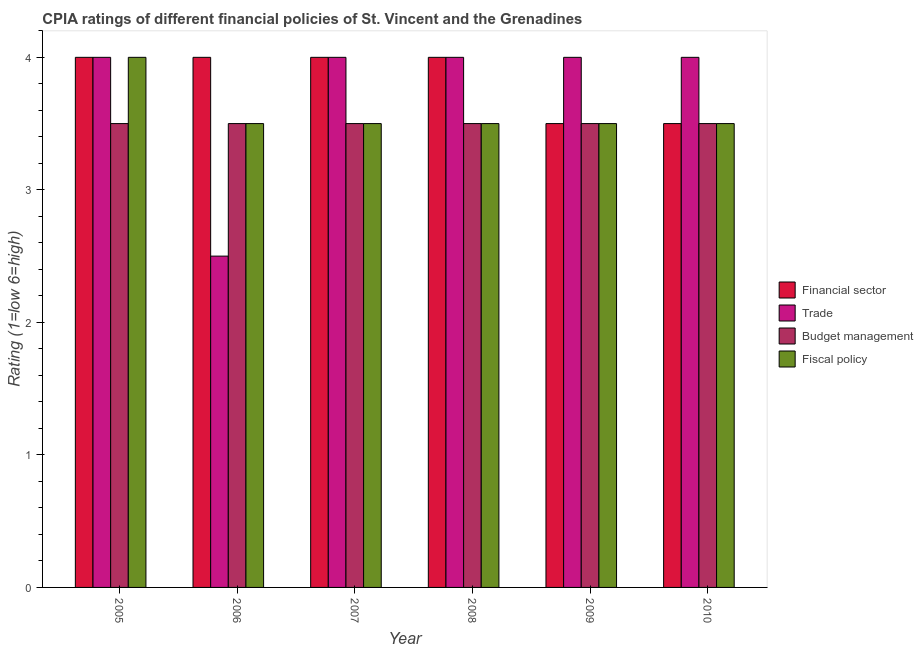How many bars are there on the 3rd tick from the right?
Provide a short and direct response. 4. What is the label of the 3rd group of bars from the left?
Provide a short and direct response. 2007. In how many cases, is the number of bars for a given year not equal to the number of legend labels?
Make the answer very short. 0. What is the cpia rating of trade in 2007?
Provide a succinct answer. 4. Across all years, what is the maximum cpia rating of financial sector?
Offer a very short reply. 4. Across all years, what is the minimum cpia rating of budget management?
Provide a short and direct response. 3.5. In which year was the cpia rating of budget management maximum?
Provide a succinct answer. 2005. What is the total cpia rating of financial sector in the graph?
Provide a short and direct response. 23. What is the difference between the cpia rating of financial sector in 2009 and the cpia rating of budget management in 2006?
Keep it short and to the point. -0.5. What is the average cpia rating of fiscal policy per year?
Provide a succinct answer. 3.58. In the year 2005, what is the difference between the cpia rating of budget management and cpia rating of trade?
Provide a short and direct response. 0. What is the ratio of the cpia rating of fiscal policy in 2009 to that in 2010?
Keep it short and to the point. 1. Is the cpia rating of fiscal policy in 2006 less than that in 2009?
Offer a very short reply. No. Is the difference between the cpia rating of budget management in 2005 and 2007 greater than the difference between the cpia rating of trade in 2005 and 2007?
Your answer should be compact. No. What is the difference between the highest and the second highest cpia rating of financial sector?
Provide a short and direct response. 0. What is the difference between the highest and the lowest cpia rating of fiscal policy?
Make the answer very short. 0.5. In how many years, is the cpia rating of budget management greater than the average cpia rating of budget management taken over all years?
Provide a short and direct response. 0. What does the 1st bar from the left in 2009 represents?
Your answer should be compact. Financial sector. What does the 1st bar from the right in 2007 represents?
Your response must be concise. Fiscal policy. Is it the case that in every year, the sum of the cpia rating of financial sector and cpia rating of trade is greater than the cpia rating of budget management?
Give a very brief answer. Yes. How many legend labels are there?
Offer a very short reply. 4. What is the title of the graph?
Keep it short and to the point. CPIA ratings of different financial policies of St. Vincent and the Grenadines. Does "Secondary general" appear as one of the legend labels in the graph?
Offer a terse response. No. What is the label or title of the X-axis?
Provide a short and direct response. Year. What is the label or title of the Y-axis?
Provide a succinct answer. Rating (1=low 6=high). What is the Rating (1=low 6=high) in Financial sector in 2005?
Offer a very short reply. 4. What is the Rating (1=low 6=high) in Fiscal policy in 2005?
Your response must be concise. 4. What is the Rating (1=low 6=high) in Financial sector in 2006?
Make the answer very short. 4. What is the Rating (1=low 6=high) in Trade in 2006?
Your answer should be very brief. 2.5. What is the Rating (1=low 6=high) of Fiscal policy in 2006?
Keep it short and to the point. 3.5. What is the Rating (1=low 6=high) of Budget management in 2007?
Your answer should be very brief. 3.5. What is the Rating (1=low 6=high) in Trade in 2008?
Make the answer very short. 4. What is the Rating (1=low 6=high) in Budget management in 2008?
Offer a very short reply. 3.5. What is the Rating (1=low 6=high) in Financial sector in 2009?
Give a very brief answer. 3.5. What is the Rating (1=low 6=high) of Trade in 2010?
Ensure brevity in your answer.  4. What is the Rating (1=low 6=high) of Budget management in 2010?
Provide a succinct answer. 3.5. What is the Rating (1=low 6=high) in Fiscal policy in 2010?
Your answer should be very brief. 3.5. Across all years, what is the maximum Rating (1=low 6=high) of Financial sector?
Offer a terse response. 4. Across all years, what is the minimum Rating (1=low 6=high) in Financial sector?
Make the answer very short. 3.5. What is the total Rating (1=low 6=high) of Financial sector in the graph?
Provide a succinct answer. 23. What is the total Rating (1=low 6=high) in Budget management in the graph?
Your answer should be compact. 21. What is the difference between the Rating (1=low 6=high) of Financial sector in 2005 and that in 2006?
Ensure brevity in your answer.  0. What is the difference between the Rating (1=low 6=high) of Budget management in 2005 and that in 2007?
Provide a succinct answer. 0. What is the difference between the Rating (1=low 6=high) of Budget management in 2005 and that in 2008?
Your response must be concise. 0. What is the difference between the Rating (1=low 6=high) in Fiscal policy in 2005 and that in 2008?
Your response must be concise. 0.5. What is the difference between the Rating (1=low 6=high) of Trade in 2005 and that in 2009?
Your answer should be compact. 0. What is the difference between the Rating (1=low 6=high) in Fiscal policy in 2005 and that in 2009?
Provide a succinct answer. 0.5. What is the difference between the Rating (1=low 6=high) of Financial sector in 2005 and that in 2010?
Offer a terse response. 0.5. What is the difference between the Rating (1=low 6=high) of Budget management in 2005 and that in 2010?
Ensure brevity in your answer.  0. What is the difference between the Rating (1=low 6=high) in Trade in 2006 and that in 2007?
Give a very brief answer. -1.5. What is the difference between the Rating (1=low 6=high) in Fiscal policy in 2006 and that in 2007?
Ensure brevity in your answer.  0. What is the difference between the Rating (1=low 6=high) of Fiscal policy in 2006 and that in 2008?
Make the answer very short. 0. What is the difference between the Rating (1=low 6=high) of Fiscal policy in 2006 and that in 2009?
Ensure brevity in your answer.  0. What is the difference between the Rating (1=low 6=high) of Financial sector in 2006 and that in 2010?
Your answer should be compact. 0.5. What is the difference between the Rating (1=low 6=high) of Trade in 2007 and that in 2008?
Make the answer very short. 0. What is the difference between the Rating (1=low 6=high) of Trade in 2007 and that in 2009?
Make the answer very short. 0. What is the difference between the Rating (1=low 6=high) of Budget management in 2007 and that in 2009?
Keep it short and to the point. 0. What is the difference between the Rating (1=low 6=high) of Fiscal policy in 2007 and that in 2009?
Provide a short and direct response. 0. What is the difference between the Rating (1=low 6=high) of Financial sector in 2007 and that in 2010?
Provide a succinct answer. 0.5. What is the difference between the Rating (1=low 6=high) of Fiscal policy in 2008 and that in 2009?
Your response must be concise. 0. What is the difference between the Rating (1=low 6=high) in Trade in 2008 and that in 2010?
Give a very brief answer. 0. What is the difference between the Rating (1=low 6=high) of Trade in 2009 and that in 2010?
Your answer should be very brief. 0. What is the difference between the Rating (1=low 6=high) of Fiscal policy in 2009 and that in 2010?
Ensure brevity in your answer.  0. What is the difference between the Rating (1=low 6=high) of Financial sector in 2005 and the Rating (1=low 6=high) of Trade in 2006?
Keep it short and to the point. 1.5. What is the difference between the Rating (1=low 6=high) in Financial sector in 2005 and the Rating (1=low 6=high) in Budget management in 2006?
Provide a short and direct response. 0.5. What is the difference between the Rating (1=low 6=high) in Financial sector in 2005 and the Rating (1=low 6=high) in Fiscal policy in 2006?
Offer a terse response. 0.5. What is the difference between the Rating (1=low 6=high) of Trade in 2005 and the Rating (1=low 6=high) of Budget management in 2006?
Ensure brevity in your answer.  0.5. What is the difference between the Rating (1=low 6=high) of Trade in 2005 and the Rating (1=low 6=high) of Fiscal policy in 2006?
Provide a short and direct response. 0.5. What is the difference between the Rating (1=low 6=high) of Financial sector in 2005 and the Rating (1=low 6=high) of Trade in 2007?
Provide a succinct answer. 0. What is the difference between the Rating (1=low 6=high) of Financial sector in 2005 and the Rating (1=low 6=high) of Fiscal policy in 2007?
Ensure brevity in your answer.  0.5. What is the difference between the Rating (1=low 6=high) of Trade in 2005 and the Rating (1=low 6=high) of Fiscal policy in 2007?
Provide a short and direct response. 0.5. What is the difference between the Rating (1=low 6=high) in Budget management in 2005 and the Rating (1=low 6=high) in Fiscal policy in 2007?
Ensure brevity in your answer.  0. What is the difference between the Rating (1=low 6=high) of Financial sector in 2005 and the Rating (1=low 6=high) of Budget management in 2008?
Your response must be concise. 0.5. What is the difference between the Rating (1=low 6=high) of Trade in 2005 and the Rating (1=low 6=high) of Budget management in 2008?
Offer a terse response. 0.5. What is the difference between the Rating (1=low 6=high) of Trade in 2005 and the Rating (1=low 6=high) of Fiscal policy in 2008?
Offer a terse response. 0.5. What is the difference between the Rating (1=low 6=high) in Budget management in 2005 and the Rating (1=low 6=high) in Fiscal policy in 2008?
Your response must be concise. 0. What is the difference between the Rating (1=low 6=high) of Financial sector in 2005 and the Rating (1=low 6=high) of Trade in 2009?
Give a very brief answer. 0. What is the difference between the Rating (1=low 6=high) of Financial sector in 2005 and the Rating (1=low 6=high) of Budget management in 2009?
Offer a very short reply. 0.5. What is the difference between the Rating (1=low 6=high) in Trade in 2005 and the Rating (1=low 6=high) in Budget management in 2009?
Your answer should be very brief. 0.5. What is the difference between the Rating (1=low 6=high) in Trade in 2005 and the Rating (1=low 6=high) in Budget management in 2010?
Your answer should be compact. 0.5. What is the difference between the Rating (1=low 6=high) of Trade in 2005 and the Rating (1=low 6=high) of Fiscal policy in 2010?
Your response must be concise. 0.5. What is the difference between the Rating (1=low 6=high) in Financial sector in 2006 and the Rating (1=low 6=high) in Fiscal policy in 2007?
Keep it short and to the point. 0.5. What is the difference between the Rating (1=low 6=high) of Financial sector in 2006 and the Rating (1=low 6=high) of Fiscal policy in 2008?
Provide a succinct answer. 0.5. What is the difference between the Rating (1=low 6=high) of Trade in 2006 and the Rating (1=low 6=high) of Budget management in 2008?
Your answer should be compact. -1. What is the difference between the Rating (1=low 6=high) of Trade in 2006 and the Rating (1=low 6=high) of Fiscal policy in 2008?
Offer a terse response. -1. What is the difference between the Rating (1=low 6=high) in Budget management in 2006 and the Rating (1=low 6=high) in Fiscal policy in 2008?
Make the answer very short. 0. What is the difference between the Rating (1=low 6=high) in Financial sector in 2006 and the Rating (1=low 6=high) in Budget management in 2009?
Ensure brevity in your answer.  0.5. What is the difference between the Rating (1=low 6=high) of Financial sector in 2006 and the Rating (1=low 6=high) of Fiscal policy in 2009?
Your answer should be compact. 0.5. What is the difference between the Rating (1=low 6=high) of Trade in 2006 and the Rating (1=low 6=high) of Fiscal policy in 2009?
Keep it short and to the point. -1. What is the difference between the Rating (1=low 6=high) in Budget management in 2006 and the Rating (1=low 6=high) in Fiscal policy in 2009?
Provide a succinct answer. 0. What is the difference between the Rating (1=low 6=high) of Financial sector in 2006 and the Rating (1=low 6=high) of Trade in 2010?
Give a very brief answer. 0. What is the difference between the Rating (1=low 6=high) in Financial sector in 2006 and the Rating (1=low 6=high) in Fiscal policy in 2010?
Offer a terse response. 0.5. What is the difference between the Rating (1=low 6=high) in Budget management in 2006 and the Rating (1=low 6=high) in Fiscal policy in 2010?
Your response must be concise. 0. What is the difference between the Rating (1=low 6=high) of Financial sector in 2007 and the Rating (1=low 6=high) of Budget management in 2008?
Your answer should be compact. 0.5. What is the difference between the Rating (1=low 6=high) of Trade in 2007 and the Rating (1=low 6=high) of Budget management in 2008?
Offer a terse response. 0.5. What is the difference between the Rating (1=low 6=high) of Financial sector in 2007 and the Rating (1=low 6=high) of Fiscal policy in 2009?
Make the answer very short. 0.5. What is the difference between the Rating (1=low 6=high) of Trade in 2007 and the Rating (1=low 6=high) of Budget management in 2009?
Offer a terse response. 0.5. What is the difference between the Rating (1=low 6=high) in Trade in 2007 and the Rating (1=low 6=high) in Fiscal policy in 2009?
Make the answer very short. 0.5. What is the difference between the Rating (1=low 6=high) of Budget management in 2007 and the Rating (1=low 6=high) of Fiscal policy in 2009?
Your answer should be very brief. 0. What is the difference between the Rating (1=low 6=high) of Financial sector in 2007 and the Rating (1=low 6=high) of Budget management in 2010?
Provide a short and direct response. 0.5. What is the difference between the Rating (1=low 6=high) in Financial sector in 2007 and the Rating (1=low 6=high) in Fiscal policy in 2010?
Your response must be concise. 0.5. What is the difference between the Rating (1=low 6=high) in Trade in 2007 and the Rating (1=low 6=high) in Budget management in 2010?
Offer a very short reply. 0.5. What is the difference between the Rating (1=low 6=high) in Budget management in 2007 and the Rating (1=low 6=high) in Fiscal policy in 2010?
Ensure brevity in your answer.  0. What is the difference between the Rating (1=low 6=high) of Financial sector in 2008 and the Rating (1=low 6=high) of Budget management in 2009?
Provide a succinct answer. 0.5. What is the difference between the Rating (1=low 6=high) in Trade in 2008 and the Rating (1=low 6=high) in Budget management in 2009?
Ensure brevity in your answer.  0.5. What is the difference between the Rating (1=low 6=high) in Trade in 2008 and the Rating (1=low 6=high) in Fiscal policy in 2009?
Offer a terse response. 0.5. What is the difference between the Rating (1=low 6=high) of Budget management in 2008 and the Rating (1=low 6=high) of Fiscal policy in 2009?
Offer a terse response. 0. What is the difference between the Rating (1=low 6=high) in Financial sector in 2008 and the Rating (1=low 6=high) in Trade in 2010?
Give a very brief answer. 0. What is the difference between the Rating (1=low 6=high) of Financial sector in 2008 and the Rating (1=low 6=high) of Budget management in 2010?
Provide a short and direct response. 0.5. What is the difference between the Rating (1=low 6=high) of Financial sector in 2008 and the Rating (1=low 6=high) of Fiscal policy in 2010?
Offer a terse response. 0.5. What is the difference between the Rating (1=low 6=high) of Financial sector in 2009 and the Rating (1=low 6=high) of Budget management in 2010?
Your answer should be compact. 0. What is the difference between the Rating (1=low 6=high) in Trade in 2009 and the Rating (1=low 6=high) in Budget management in 2010?
Provide a short and direct response. 0.5. What is the difference between the Rating (1=low 6=high) in Trade in 2009 and the Rating (1=low 6=high) in Fiscal policy in 2010?
Give a very brief answer. 0.5. What is the average Rating (1=low 6=high) of Financial sector per year?
Your answer should be very brief. 3.83. What is the average Rating (1=low 6=high) of Trade per year?
Provide a short and direct response. 3.75. What is the average Rating (1=low 6=high) in Budget management per year?
Make the answer very short. 3.5. What is the average Rating (1=low 6=high) in Fiscal policy per year?
Your answer should be compact. 3.58. In the year 2005, what is the difference between the Rating (1=low 6=high) of Financial sector and Rating (1=low 6=high) of Trade?
Your answer should be very brief. 0. In the year 2005, what is the difference between the Rating (1=low 6=high) of Financial sector and Rating (1=low 6=high) of Budget management?
Keep it short and to the point. 0.5. In the year 2005, what is the difference between the Rating (1=low 6=high) in Trade and Rating (1=low 6=high) in Fiscal policy?
Offer a terse response. 0. In the year 2006, what is the difference between the Rating (1=low 6=high) of Financial sector and Rating (1=low 6=high) of Trade?
Your response must be concise. 1.5. In the year 2006, what is the difference between the Rating (1=low 6=high) in Financial sector and Rating (1=low 6=high) in Budget management?
Provide a short and direct response. 0.5. In the year 2006, what is the difference between the Rating (1=low 6=high) of Financial sector and Rating (1=low 6=high) of Fiscal policy?
Make the answer very short. 0.5. In the year 2006, what is the difference between the Rating (1=low 6=high) of Trade and Rating (1=low 6=high) of Fiscal policy?
Ensure brevity in your answer.  -1. In the year 2006, what is the difference between the Rating (1=low 6=high) in Budget management and Rating (1=low 6=high) in Fiscal policy?
Offer a very short reply. 0. In the year 2007, what is the difference between the Rating (1=low 6=high) in Financial sector and Rating (1=low 6=high) in Budget management?
Provide a short and direct response. 0.5. In the year 2007, what is the difference between the Rating (1=low 6=high) of Financial sector and Rating (1=low 6=high) of Fiscal policy?
Give a very brief answer. 0.5. In the year 2007, what is the difference between the Rating (1=low 6=high) of Trade and Rating (1=low 6=high) of Fiscal policy?
Offer a terse response. 0.5. In the year 2007, what is the difference between the Rating (1=low 6=high) in Budget management and Rating (1=low 6=high) in Fiscal policy?
Keep it short and to the point. 0. In the year 2008, what is the difference between the Rating (1=low 6=high) in Financial sector and Rating (1=low 6=high) in Trade?
Give a very brief answer. 0. In the year 2008, what is the difference between the Rating (1=low 6=high) of Financial sector and Rating (1=low 6=high) of Budget management?
Offer a terse response. 0.5. In the year 2008, what is the difference between the Rating (1=low 6=high) in Trade and Rating (1=low 6=high) in Fiscal policy?
Provide a short and direct response. 0.5. In the year 2009, what is the difference between the Rating (1=low 6=high) of Financial sector and Rating (1=low 6=high) of Budget management?
Ensure brevity in your answer.  0. In the year 2009, what is the difference between the Rating (1=low 6=high) of Financial sector and Rating (1=low 6=high) of Fiscal policy?
Your response must be concise. 0. In the year 2009, what is the difference between the Rating (1=low 6=high) of Trade and Rating (1=low 6=high) of Fiscal policy?
Ensure brevity in your answer.  0.5. In the year 2010, what is the difference between the Rating (1=low 6=high) in Financial sector and Rating (1=low 6=high) in Budget management?
Your answer should be very brief. 0. In the year 2010, what is the difference between the Rating (1=low 6=high) of Trade and Rating (1=low 6=high) of Fiscal policy?
Your answer should be compact. 0.5. What is the ratio of the Rating (1=low 6=high) in Financial sector in 2005 to that in 2006?
Make the answer very short. 1. What is the ratio of the Rating (1=low 6=high) in Budget management in 2005 to that in 2006?
Make the answer very short. 1. What is the ratio of the Rating (1=low 6=high) in Fiscal policy in 2005 to that in 2006?
Give a very brief answer. 1.14. What is the ratio of the Rating (1=low 6=high) in Fiscal policy in 2005 to that in 2007?
Your answer should be very brief. 1.14. What is the ratio of the Rating (1=low 6=high) in Financial sector in 2005 to that in 2008?
Ensure brevity in your answer.  1. What is the ratio of the Rating (1=low 6=high) of Financial sector in 2005 to that in 2009?
Make the answer very short. 1.14. What is the ratio of the Rating (1=low 6=high) in Trade in 2005 to that in 2009?
Offer a very short reply. 1. What is the ratio of the Rating (1=low 6=high) in Budget management in 2005 to that in 2009?
Give a very brief answer. 1. What is the ratio of the Rating (1=low 6=high) in Budget management in 2005 to that in 2010?
Your answer should be very brief. 1. What is the ratio of the Rating (1=low 6=high) of Financial sector in 2006 to that in 2007?
Your answer should be very brief. 1. What is the ratio of the Rating (1=low 6=high) of Budget management in 2006 to that in 2007?
Your response must be concise. 1. What is the ratio of the Rating (1=low 6=high) in Trade in 2006 to that in 2008?
Make the answer very short. 0.62. What is the ratio of the Rating (1=low 6=high) in Financial sector in 2006 to that in 2009?
Offer a terse response. 1.14. What is the ratio of the Rating (1=low 6=high) of Fiscal policy in 2006 to that in 2009?
Offer a terse response. 1. What is the ratio of the Rating (1=low 6=high) in Financial sector in 2006 to that in 2010?
Offer a very short reply. 1.14. What is the ratio of the Rating (1=low 6=high) in Budget management in 2006 to that in 2010?
Offer a terse response. 1. What is the ratio of the Rating (1=low 6=high) in Fiscal policy in 2006 to that in 2010?
Ensure brevity in your answer.  1. What is the ratio of the Rating (1=low 6=high) in Trade in 2007 to that in 2008?
Ensure brevity in your answer.  1. What is the ratio of the Rating (1=low 6=high) of Budget management in 2007 to that in 2008?
Your answer should be compact. 1. What is the ratio of the Rating (1=low 6=high) of Fiscal policy in 2007 to that in 2008?
Your response must be concise. 1. What is the ratio of the Rating (1=low 6=high) in Financial sector in 2007 to that in 2009?
Give a very brief answer. 1.14. What is the ratio of the Rating (1=low 6=high) in Trade in 2007 to that in 2009?
Keep it short and to the point. 1. What is the ratio of the Rating (1=low 6=high) of Budget management in 2007 to that in 2009?
Your answer should be compact. 1. What is the ratio of the Rating (1=low 6=high) in Financial sector in 2007 to that in 2010?
Make the answer very short. 1.14. What is the ratio of the Rating (1=low 6=high) of Trade in 2007 to that in 2010?
Make the answer very short. 1. What is the ratio of the Rating (1=low 6=high) of Financial sector in 2008 to that in 2009?
Keep it short and to the point. 1.14. What is the ratio of the Rating (1=low 6=high) in Trade in 2008 to that in 2009?
Offer a terse response. 1. What is the ratio of the Rating (1=low 6=high) in Budget management in 2008 to that in 2009?
Ensure brevity in your answer.  1. What is the ratio of the Rating (1=low 6=high) of Fiscal policy in 2008 to that in 2009?
Your answer should be very brief. 1. What is the ratio of the Rating (1=low 6=high) in Budget management in 2008 to that in 2010?
Offer a terse response. 1. What is the ratio of the Rating (1=low 6=high) of Fiscal policy in 2008 to that in 2010?
Your answer should be compact. 1. What is the difference between the highest and the second highest Rating (1=low 6=high) of Trade?
Offer a terse response. 0. What is the difference between the highest and the lowest Rating (1=low 6=high) in Financial sector?
Offer a terse response. 0.5. What is the difference between the highest and the lowest Rating (1=low 6=high) of Trade?
Ensure brevity in your answer.  1.5. What is the difference between the highest and the lowest Rating (1=low 6=high) of Budget management?
Offer a terse response. 0. What is the difference between the highest and the lowest Rating (1=low 6=high) of Fiscal policy?
Ensure brevity in your answer.  0.5. 